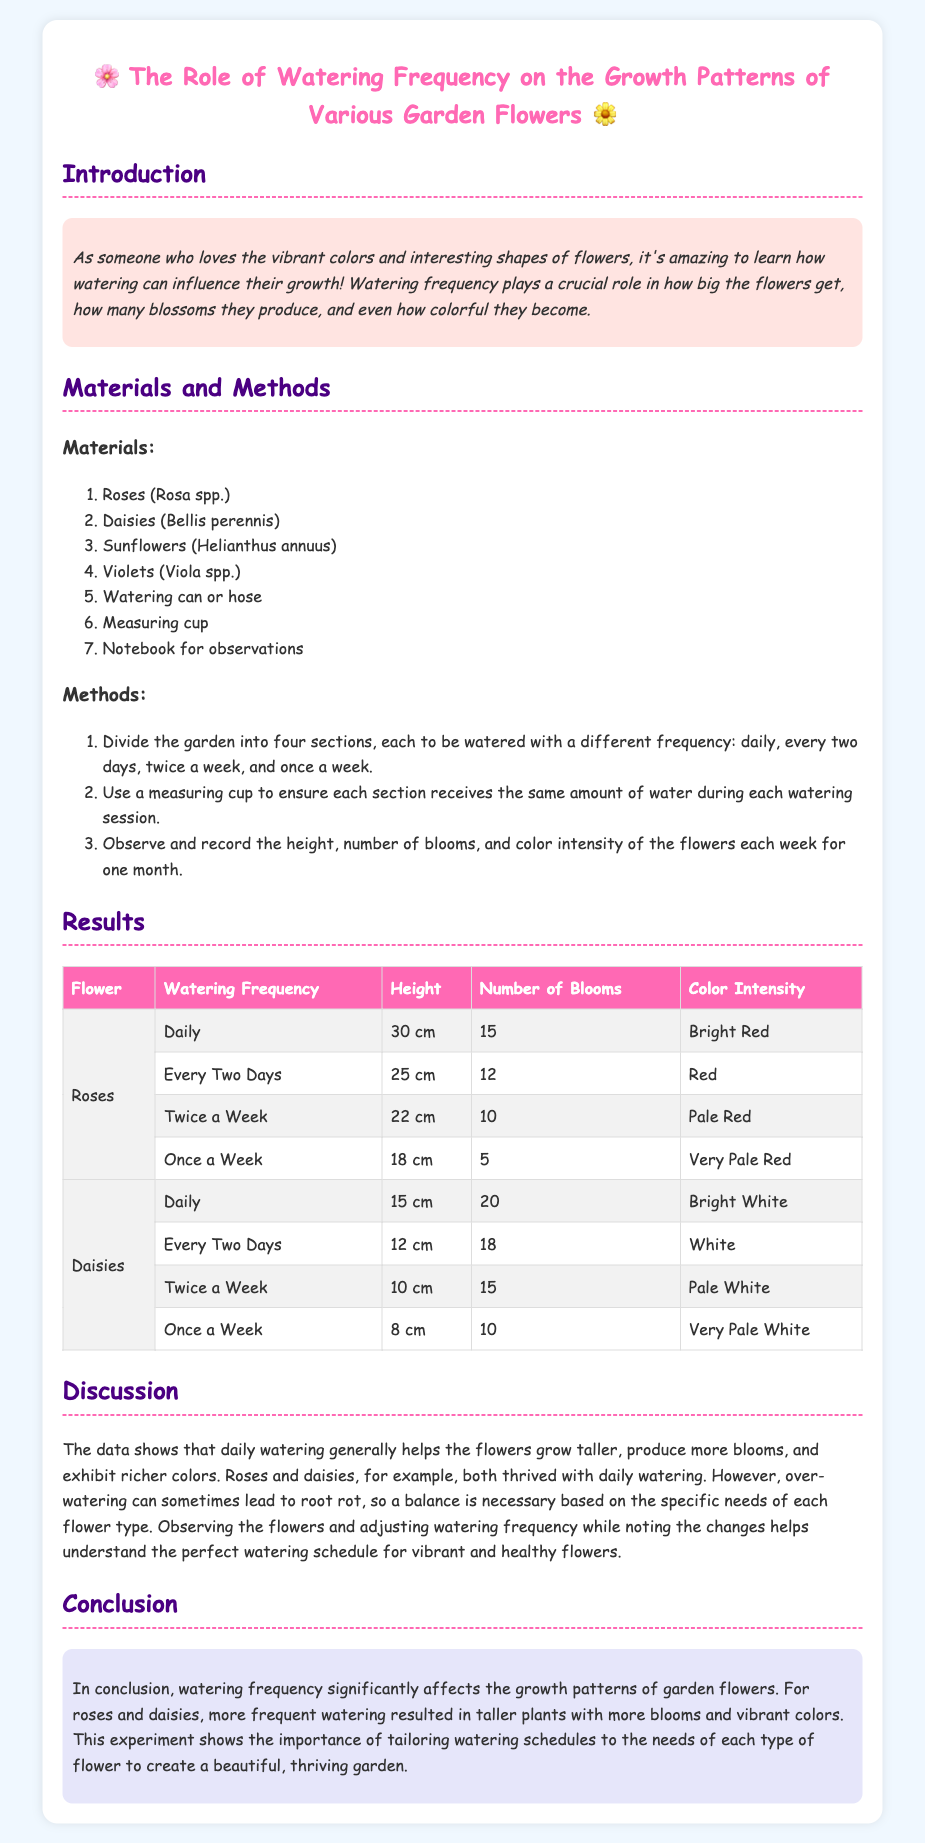what is the title of the lab report? The title of the lab report is the main heading that summarizes the experiment's focus and findings.
Answer: The Role of Watering Frequency on the Growth Patterns of Various Garden Flowers how many flowers were tested in the experiment? The number of flower types mentioned in the materials section indicates how many were tested.
Answer: Four which flower had the highest number of blooms when watered daily? The number of blooms for each flower type at the daily watering frequency reveals which had the highest.
Answer: Daisies what color were the roses watered once a week? The color intensity of roses at that watering frequency shows the outcome of less frequent watering.
Answer: Very Pale Red what was the height of sunflowers when watered daily? The table displays the height of sunflowers under daily watering conditions and specifies the measurement.
Answer: Not provided which type of watering resulted in the tallest roses? By comparing the height of roses across different watering frequencies, the tallest can be identified.
Answer: Daily what is a potential risk mentioned regarding watering flowers? The document notes a concern related to caring for flowers in relation to their watering routines.
Answer: Root rot what was the main conclusion of the experiment? The conclusion summarizes the findings and significance of watering frequency on flower growth.
Answer: Watering frequency significantly affects the growth patterns of garden flowers 